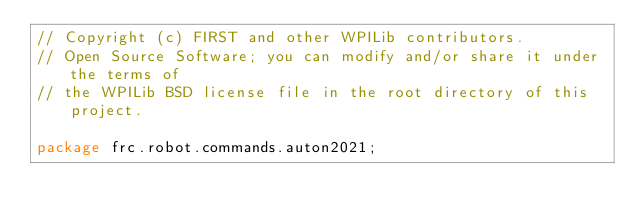<code> <loc_0><loc_0><loc_500><loc_500><_Java_>// Copyright (c) FIRST and other WPILib contributors.
// Open Source Software; you can modify and/or share it under the terms of
// the WPILib BSD license file in the root directory of this project.

package frc.robot.commands.auton2021;
</code> 